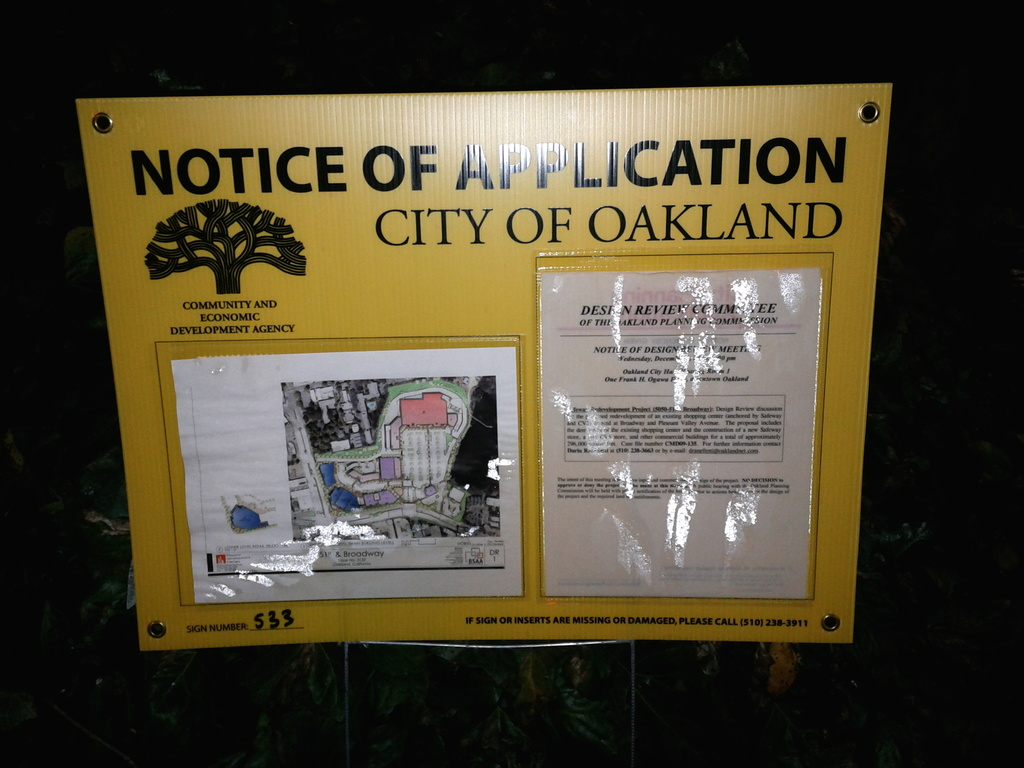What might be the implications of the development project discussed on this notice? The proposed project could have a variety of implications. It could lead to increased commercial activity and elevate property values in the area. However, it might also bring challenges such as traffic congestion and displacement of current residents or businesses. Public hearings, like the one announced, are crucial as they provide a platform for local stakeholders to voice support, concerns, and suggestions regarding such transformative projects. 